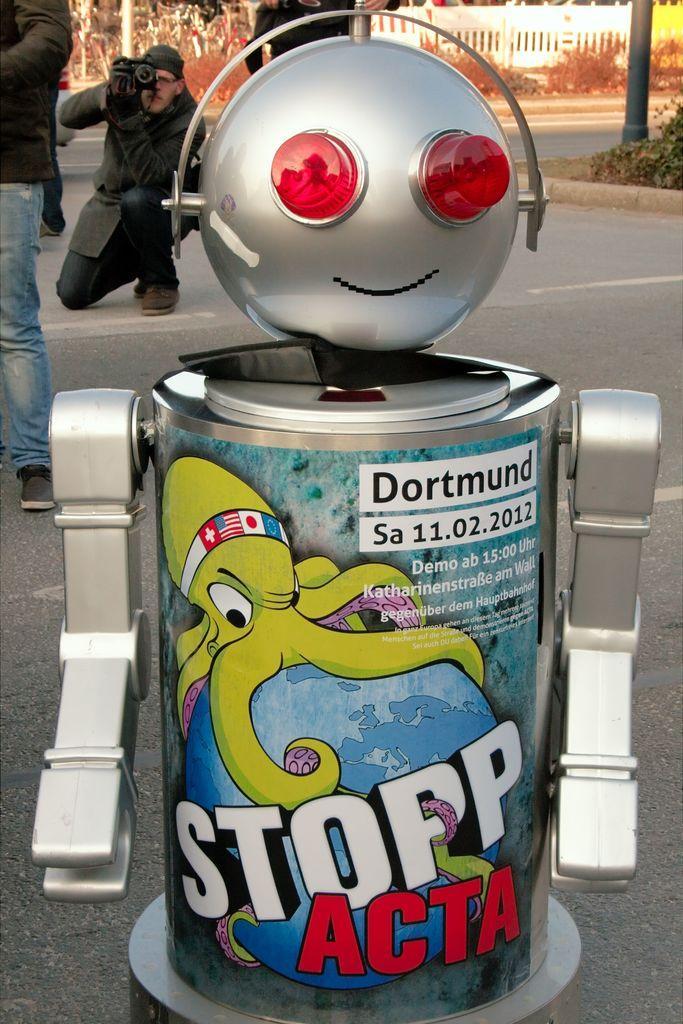How would you summarize this image in a sentence or two? It is in the shape of a robot, on the left side a man is taking the photograph by sitting on the road. 